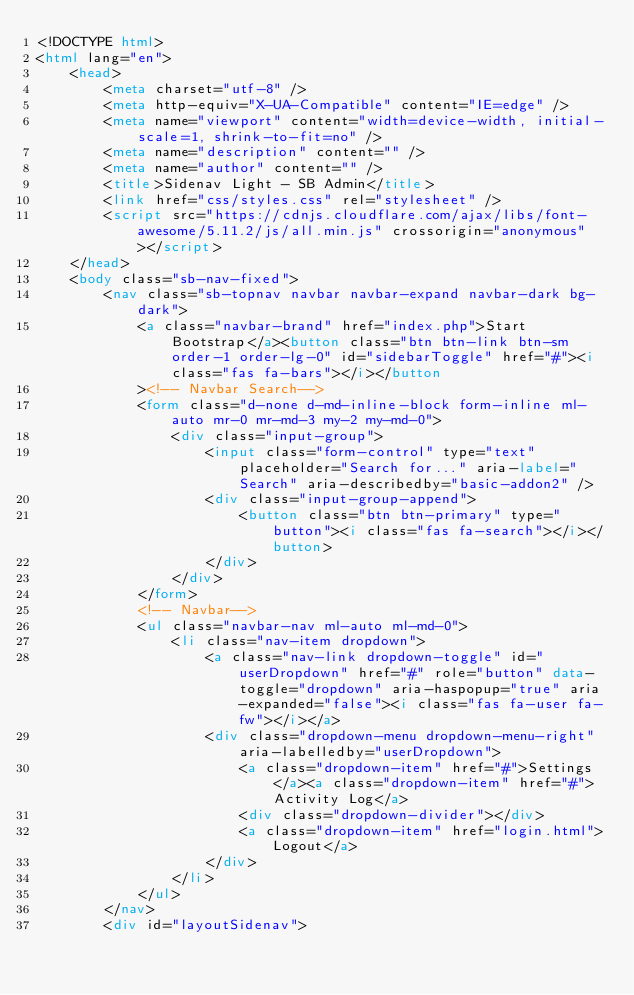<code> <loc_0><loc_0><loc_500><loc_500><_HTML_><!DOCTYPE html>
<html lang="en">
    <head>
        <meta charset="utf-8" />
        <meta http-equiv="X-UA-Compatible" content="IE=edge" />
        <meta name="viewport" content="width=device-width, initial-scale=1, shrink-to-fit=no" />
        <meta name="description" content="" />
        <meta name="author" content="" />
        <title>Sidenav Light - SB Admin</title>
        <link href="css/styles.css" rel="stylesheet" />
        <script src="https://cdnjs.cloudflare.com/ajax/libs/font-awesome/5.11.2/js/all.min.js" crossorigin="anonymous"></script>
    </head>
    <body class="sb-nav-fixed">
        <nav class="sb-topnav navbar navbar-expand navbar-dark bg-dark">
            <a class="navbar-brand" href="index.php">Start Bootstrap</a><button class="btn btn-link btn-sm order-1 order-lg-0" id="sidebarToggle" href="#"><i class="fas fa-bars"></i></button
            ><!-- Navbar Search-->
            <form class="d-none d-md-inline-block form-inline ml-auto mr-0 mr-md-3 my-2 my-md-0">
                <div class="input-group">
                    <input class="form-control" type="text" placeholder="Search for..." aria-label="Search" aria-describedby="basic-addon2" />
                    <div class="input-group-append">
                        <button class="btn btn-primary" type="button"><i class="fas fa-search"></i></button>
                    </div>
                </div>
            </form>
            <!-- Navbar-->
            <ul class="navbar-nav ml-auto ml-md-0">
                <li class="nav-item dropdown">
                    <a class="nav-link dropdown-toggle" id="userDropdown" href="#" role="button" data-toggle="dropdown" aria-haspopup="true" aria-expanded="false"><i class="fas fa-user fa-fw"></i></a>
                    <div class="dropdown-menu dropdown-menu-right" aria-labelledby="userDropdown">
                        <a class="dropdown-item" href="#">Settings</a><a class="dropdown-item" href="#">Activity Log</a>
                        <div class="dropdown-divider"></div>
                        <a class="dropdown-item" href="login.html">Logout</a>
                    </div>
                </li>
            </ul>
        </nav>
        <div id="layoutSidenav"></code> 